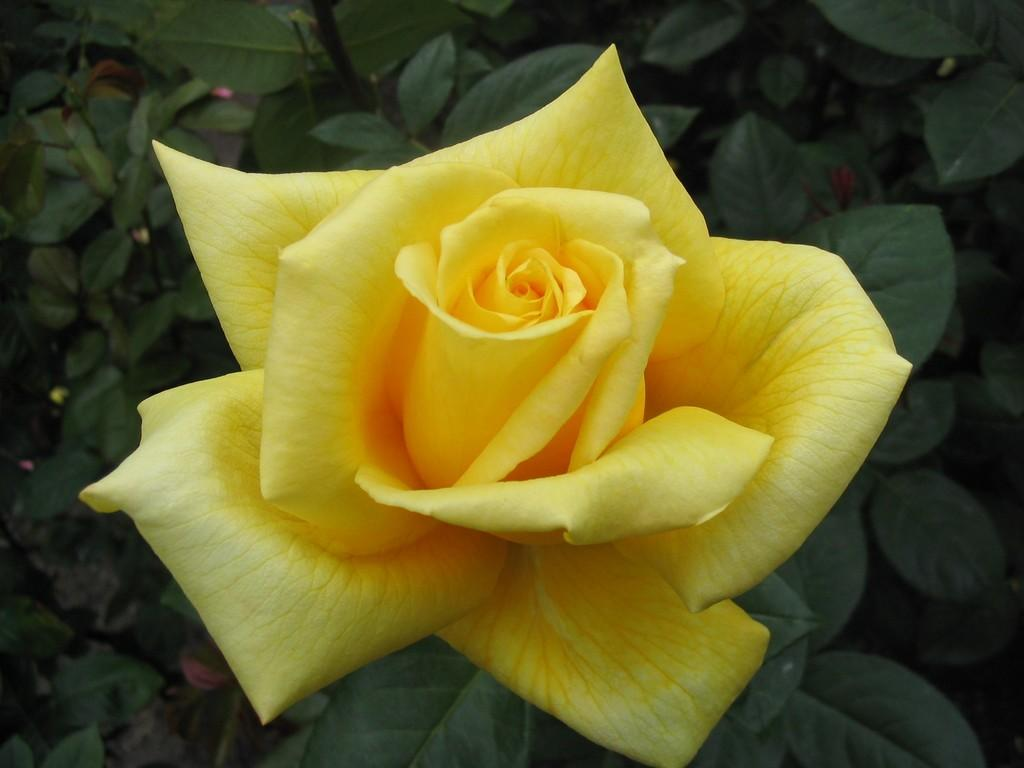What type of flower is in the image? There is a yellow rose in the image. What else can be seen in the image besides the yellow rose? There are plants in the image. What type of powder is being used to fertilize the plants in the image? There is no powder or indication of fertilization in the image; it only shows a yellow rose and other plants. 